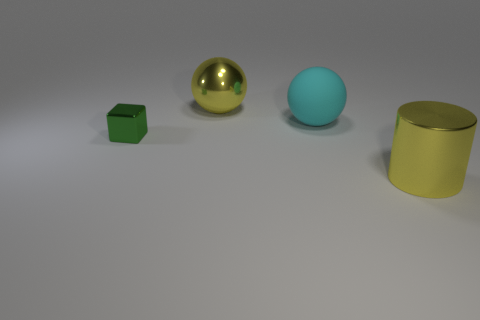Add 2 big yellow cylinders. How many objects exist? 6 Subtract all cylinders. How many objects are left? 3 Subtract 0 red cubes. How many objects are left? 4 Subtract all tiny red shiny balls. Subtract all tiny green metal objects. How many objects are left? 3 Add 2 large rubber balls. How many large rubber balls are left? 3 Add 1 yellow things. How many yellow things exist? 3 